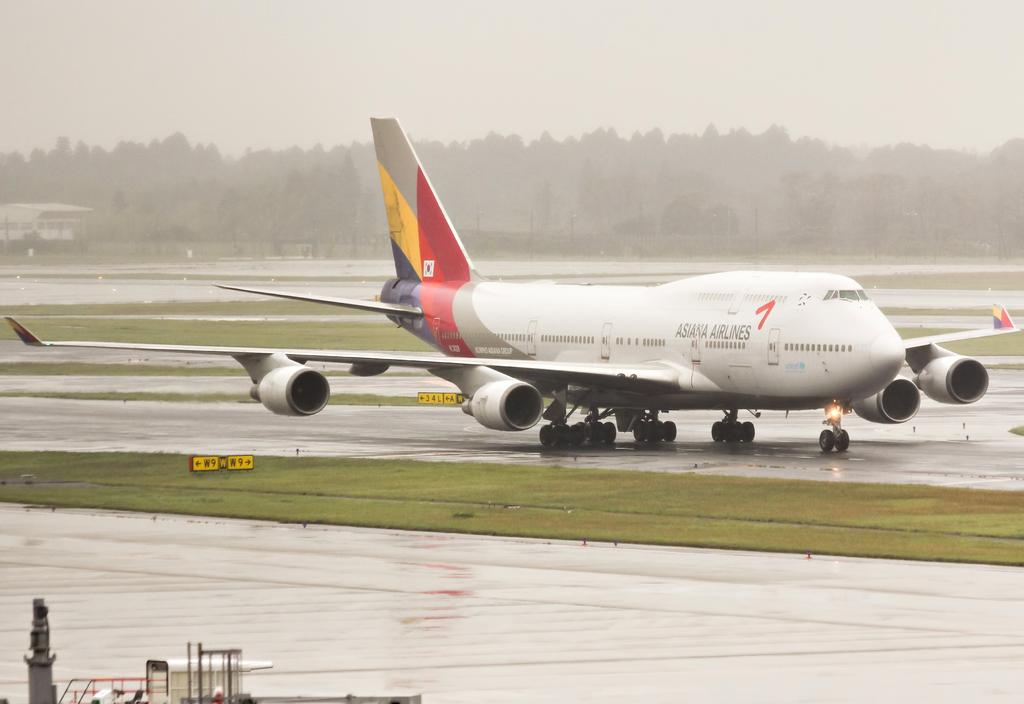What airline does the plane belong to?
Give a very brief answer. Asiana. 